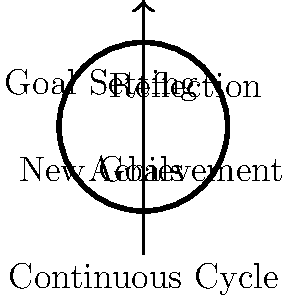In the context of sports psychology, how does the Möbius strip concept relate to the cycle of goal-setting and achievement? Explain how this continuous process can be used to enhance an athlete's performance and motivation. To understand the relationship between the Möbius strip and the goal-setting/achievement cycle in sports psychology, let's break it down step-by-step:

1. Möbius strip properties:
   - The Möbius strip is a topological object with only one side and one edge.
   - It represents continuity and infinite loops.

2. Goal-setting and achievement cycle:
   a) Goal Setting: Athletes set specific, measurable objectives.
   b) Action: They work towards these goals through training and competition.
   c) Achievement: Athletes reach their goals or make progress towards them.
   d) Reflection: They evaluate their performance and outcomes.
   e) New Goals: Based on reflection, they set new or adjusted goals.

3. Continuous nature:
   - Like the Möbius strip, this cycle is continuous and never-ending.
   - Each phase seamlessly transitions into the next without a clear "end" point.

4. Performance enhancement:
   - Constant goal-setting keeps athletes motivated and focused.
   - Regular achievements boost confidence and self-efficacy.
   - Reflection promotes learning and adaptation.
   - The cycle ensures continuous improvement and prevents stagnation.

5. Motivation:
   - Short-term goals provide immediate motivation.
   - Long-term goals offer a broader vision and purpose.
   - The cycle creates a sense of progress and accomplishment.

6. Adaptability:
   - The continuous nature allows for quick adjustments based on performance.
   - It promotes resilience by encouraging athletes to set new goals after setbacks.

7. Psychological benefits:
   - Provides structure and purpose to training.
   - Enhances self-awareness through regular reflection.
   - Builds mental toughness through consistent challenge and achievement.

By visualizing this process as a Möbius strip, coaches and athletes can understand the interconnected and ongoing nature of performance improvement, leading to sustained motivation and development.
Answer: Continuous, adaptive process for sustained motivation and performance improvement 